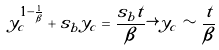<formula> <loc_0><loc_0><loc_500><loc_500>y _ { c } ^ { 1 - \frac { 1 } { \beta } } + s _ { b } y _ { c } = \frac { s _ { b } t } { \beta } \rightarrow y _ { c } \sim \frac { t } { \beta }</formula> 